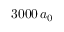Convert formula to latex. <formula><loc_0><loc_0><loc_500><loc_500>3 0 0 0 \, a _ { 0 }</formula> 